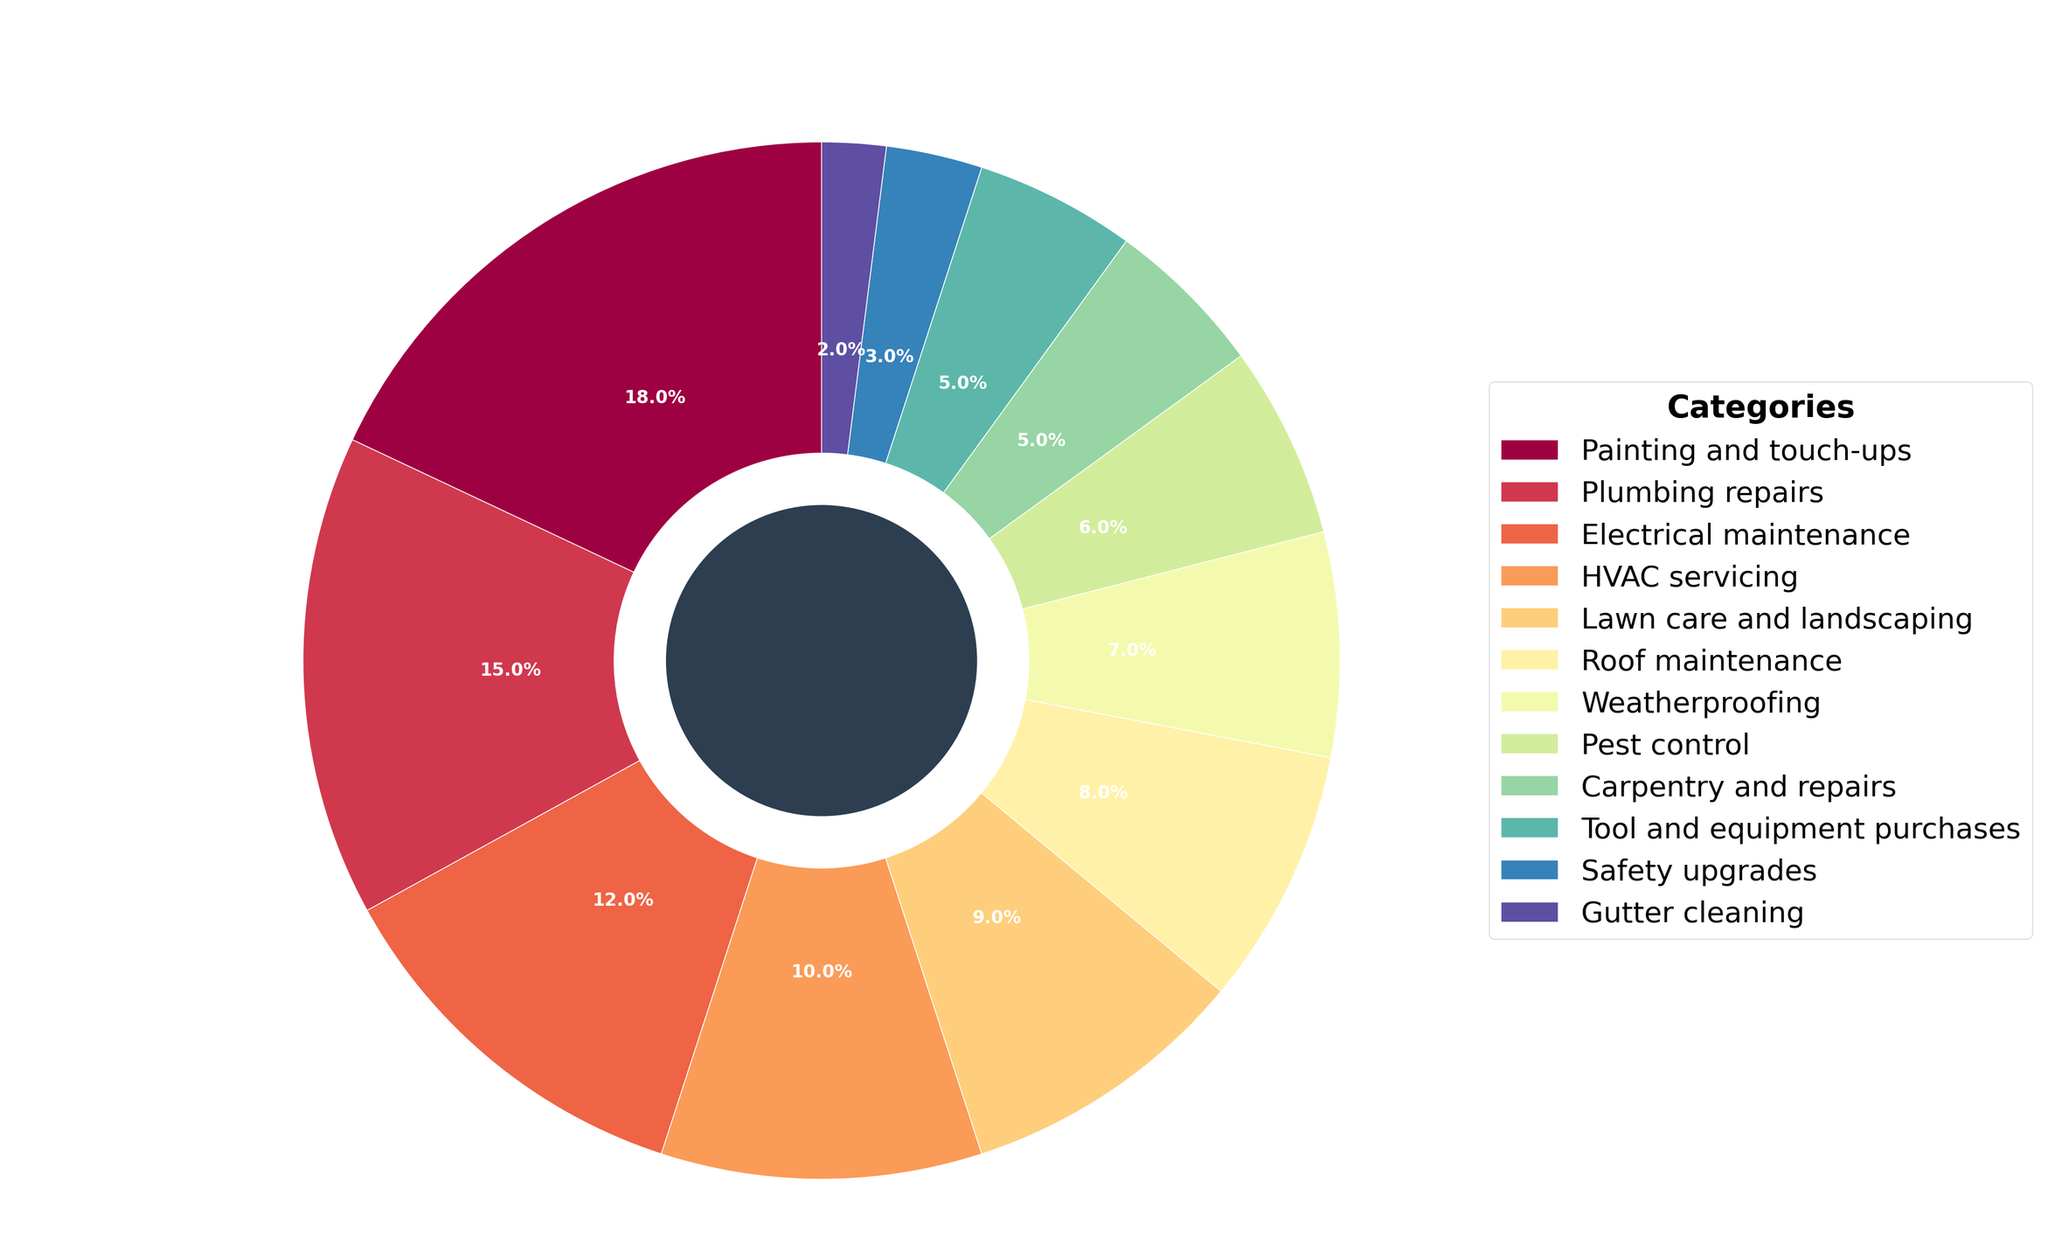Which category has the highest percentage allocation in the home maintenance budget? The figure shows multiple categories with their respective percentage allocations in a pie chart. By visually scanning the pie slices, we can see that "Painting and touch-ups" has the largest slice which represents the highest percentage allocation.
Answer: Painting and touch-ups What is the combined percentage allocation for Plumbing repairs and Electrical maintenance? To find the combined percentage allocation, we need to add the percentages for Plumbing repairs and Electrical maintenance. From the figure, Plumbing repairs is 15% and Electrical maintenance is 12%. So, the combined allocation is 15% + 12% = 27%.
Answer: 27% Which category has a smaller allocation: Roof maintenance or Weatherproofing? By comparing the sizes of the pie slices for Roof maintenance and Weatherproofing, we see that Roof maintenance has an 8% allocation and Weatherproofing has a 7% allocation. Therefore, Weatherproofing has a smaller allocation.
Answer: Weatherproofing How many categories have an allocation of less than 10%? We identify the categories with less than 10% from the pie chart: Lawn care and landscaping (9%), Roof maintenance (8%), Weatherproofing (7%), Pest control (6%), Carpentry and repairs (5%), Tool and equipment purchases (5%), Safety upgrades (3%), and Gutter cleaning (2%). There are 8 such categories.
Answer: 8 Which category has a percentage allocation closest to that of HVAC servicing? HVAC servicing has an allocation of 10%. By visually inspecting the pie chart for the slice closest in size, we find that Lawn care and landscaping has a 9% allocation, which is the closest to 10%.
Answer: Lawn care and landscaping What's the total percentage allocation for categories with 5% allocation each? We need to add the percentages for categories that have 5% allocation each. From the chart, Carpentry and repairs and Tool and equipment purchases each have a 5% allocation. So, the total is 5% + 5% = 10%.
Answer: 10% Which categories combined give almost half (approx. 50%) of the total budget? To find this, we sum up the largest percentages until we get close to 50%. Painting and touch-ups (18%), Plumbing repairs (15%), and Electrical maintenance (12%) add up to 18% + 15% + 12% = 45%. Adding HVAC servicing (10%) to this makes 45% + 10% = 55%, which is slightly above 50%. Thus, Painting and touch-ups, Plumbing repairs, and Electrical maintenance combined give the closest to half of the budget.
Answer: Painting and touch-ups, Plumbing repairs, and Electrical maintenance If we combine the percentage allocations of Pest control, Safety upgrades, and Gutter cleaning, will it surpass that of HVAC servicing? We sum up the allocations of Pest control (6%), Safety upgrades (3%), and Gutter cleaning (2%). The total is 6% + 3% + 2% = 11%. Comparing this with HVAC servicing's 10%, 11% is greater than 10%.
Answer: Yes What is the difference in percentage between Lawn care and landscaping and Safety upgrades? Lawn care and landscaping has a 9% allocation while Safety upgrades have a 3% allocation. The difference is calculated as 9% - 3% = 6%.
Answer: 6% Which categories combined make up exactly 21% of the budget? We look for combinations of category percentages that add up to 21%. Painting and touch-ups is 18% and adding Gutter cleaning which is 2%, and Safety upgrades which is 3%, we get 18% + 2% + 3% = 23%. Another possible combination is Plumbing repairs (15%) and Weatherproofing (7%) giving 15% + 7% = 22%. Finally, adding Electrical maintenance (12%) to Tool and equipment purchases (5%) and Safety upgrades (3%) gives 12% + 5% + 3% = 20%. None make exactly 21%. Thus, we need a combination of smaller categories to achieve exactly 21%. Grouping Weatherproofing (7%), Pest control (6%), and Carpentry and repairs (5%) gives precisely 21%.
Answer: Weatherproofing, Pest control, and Carpentry and repairs 